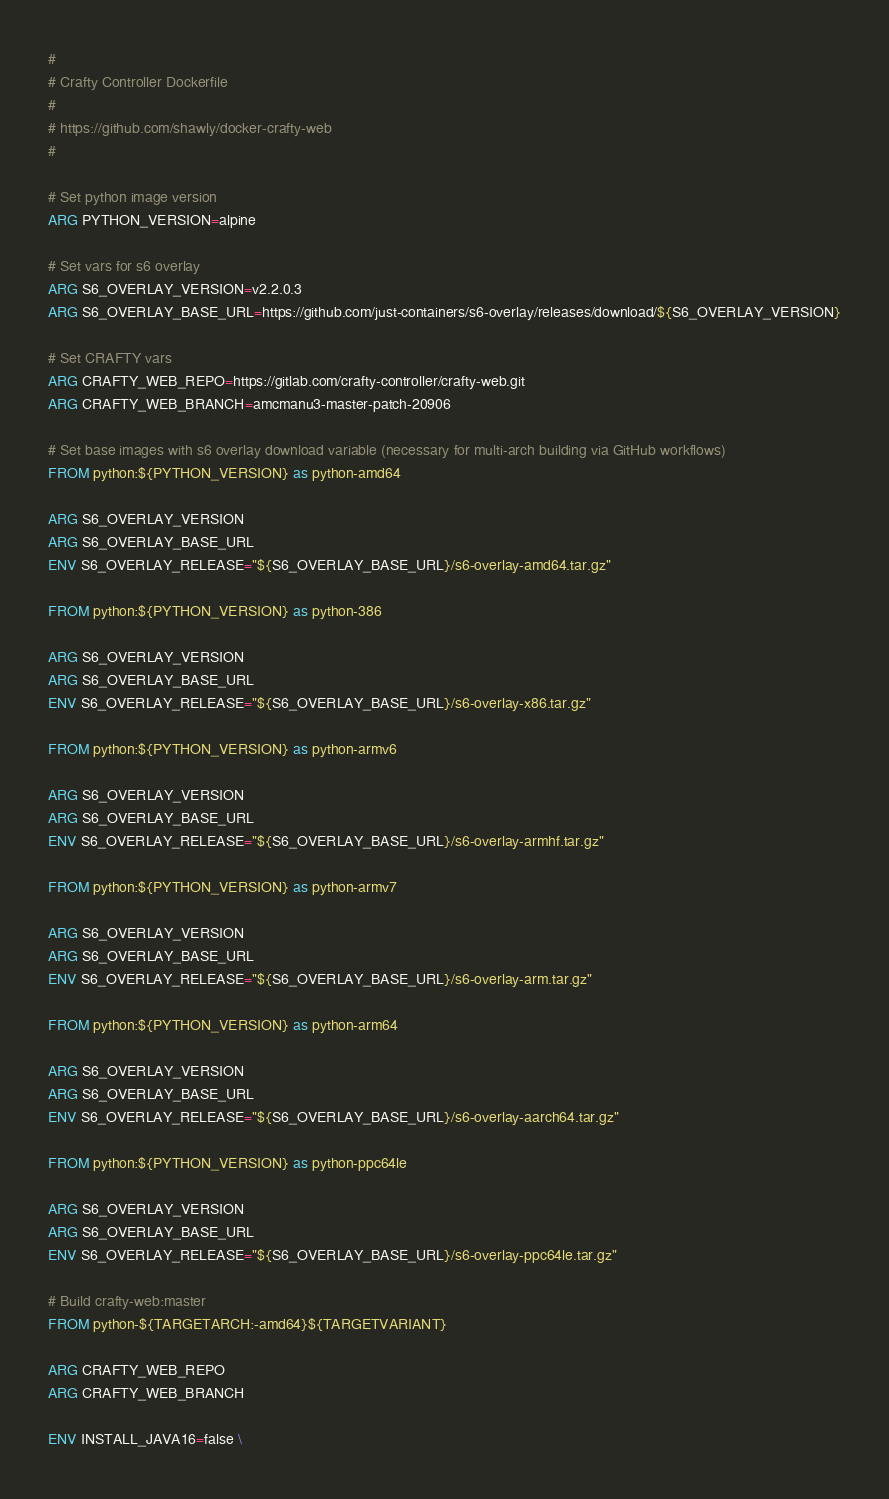<code> <loc_0><loc_0><loc_500><loc_500><_Dockerfile_>#
# Crafty Controller Dockerfile
#
# https://github.com/shawly/docker-crafty-web
#

# Set python image version
ARG PYTHON_VERSION=alpine

# Set vars for s6 overlay
ARG S6_OVERLAY_VERSION=v2.2.0.3
ARG S6_OVERLAY_BASE_URL=https://github.com/just-containers/s6-overlay/releases/download/${S6_OVERLAY_VERSION}

# Set CRAFTY vars
ARG CRAFTY_WEB_REPO=https://gitlab.com/crafty-controller/crafty-web.git
ARG CRAFTY_WEB_BRANCH=amcmanu3-master-patch-20906

# Set base images with s6 overlay download variable (necessary for multi-arch building via GitHub workflows)
FROM python:${PYTHON_VERSION} as python-amd64

ARG S6_OVERLAY_VERSION
ARG S6_OVERLAY_BASE_URL
ENV S6_OVERLAY_RELEASE="${S6_OVERLAY_BASE_URL}/s6-overlay-amd64.tar.gz"

FROM python:${PYTHON_VERSION} as python-386

ARG S6_OVERLAY_VERSION
ARG S6_OVERLAY_BASE_URL
ENV S6_OVERLAY_RELEASE="${S6_OVERLAY_BASE_URL}/s6-overlay-x86.tar.gz"

FROM python:${PYTHON_VERSION} as python-armv6

ARG S6_OVERLAY_VERSION
ARG S6_OVERLAY_BASE_URL
ENV S6_OVERLAY_RELEASE="${S6_OVERLAY_BASE_URL}/s6-overlay-armhf.tar.gz"

FROM python:${PYTHON_VERSION} as python-armv7

ARG S6_OVERLAY_VERSION
ARG S6_OVERLAY_BASE_URL
ENV S6_OVERLAY_RELEASE="${S6_OVERLAY_BASE_URL}/s6-overlay-arm.tar.gz"

FROM python:${PYTHON_VERSION} as python-arm64

ARG S6_OVERLAY_VERSION
ARG S6_OVERLAY_BASE_URL
ENV S6_OVERLAY_RELEASE="${S6_OVERLAY_BASE_URL}/s6-overlay-aarch64.tar.gz"

FROM python:${PYTHON_VERSION} as python-ppc64le

ARG S6_OVERLAY_VERSION
ARG S6_OVERLAY_BASE_URL
ENV S6_OVERLAY_RELEASE="${S6_OVERLAY_BASE_URL}/s6-overlay-ppc64le.tar.gz"

# Build crafty-web:master
FROM python-${TARGETARCH:-amd64}${TARGETVARIANT}

ARG CRAFTY_WEB_REPO
ARG CRAFTY_WEB_BRANCH

ENV INSTALL_JAVA16=false \</code> 